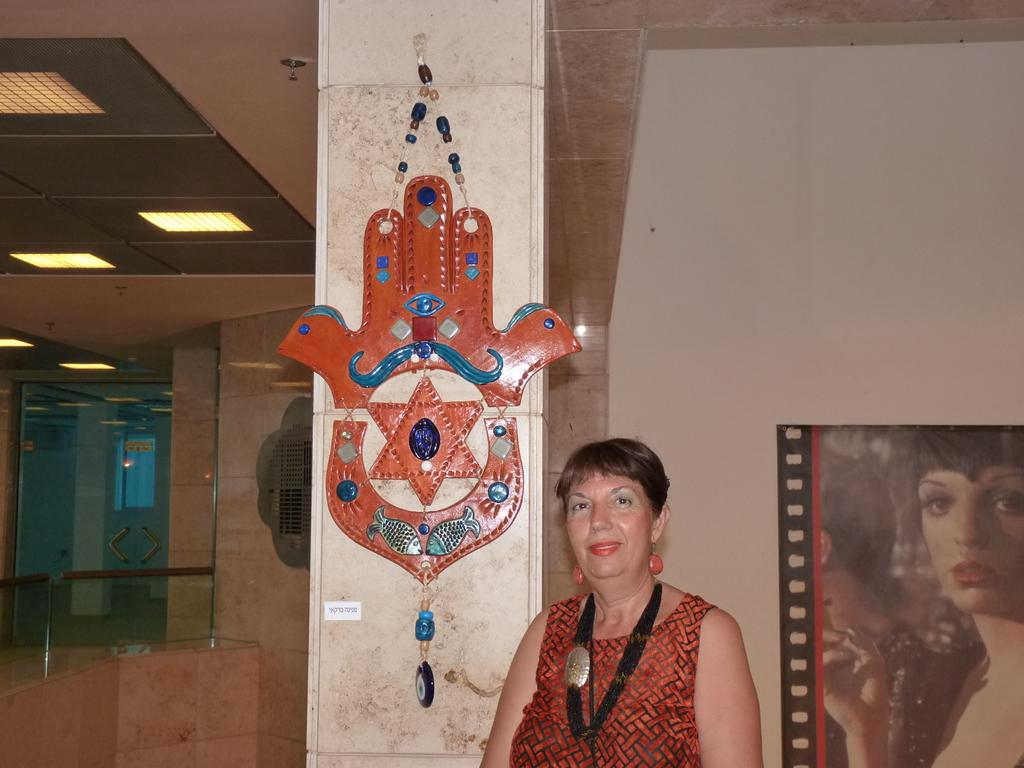Who is present in the image? There is a woman in the image. What is the woman doing in the image? The woman is posing for a camera. What is the woman's facial expression in the image? The woman is smiling. What architectural feature can be seen in the image? There is a pillar in the image. What type of signage is present in the image? There is a poster in the image. What type of lighting is visible in the image? There are lights in the image. What type of material is present in the image? There is glass in the image. What type of structure can be seen in the image? There is a wall in the image. What object is present in the image? There is an object in the image. What part of the room is visible in the image? The ceiling is visible in the image. How many trees are visible in the image? There are no trees visible in the image. What type of trousers is the woman wearing in the image? The image does not show the woman's trousers, so it cannot be determined from the image. 